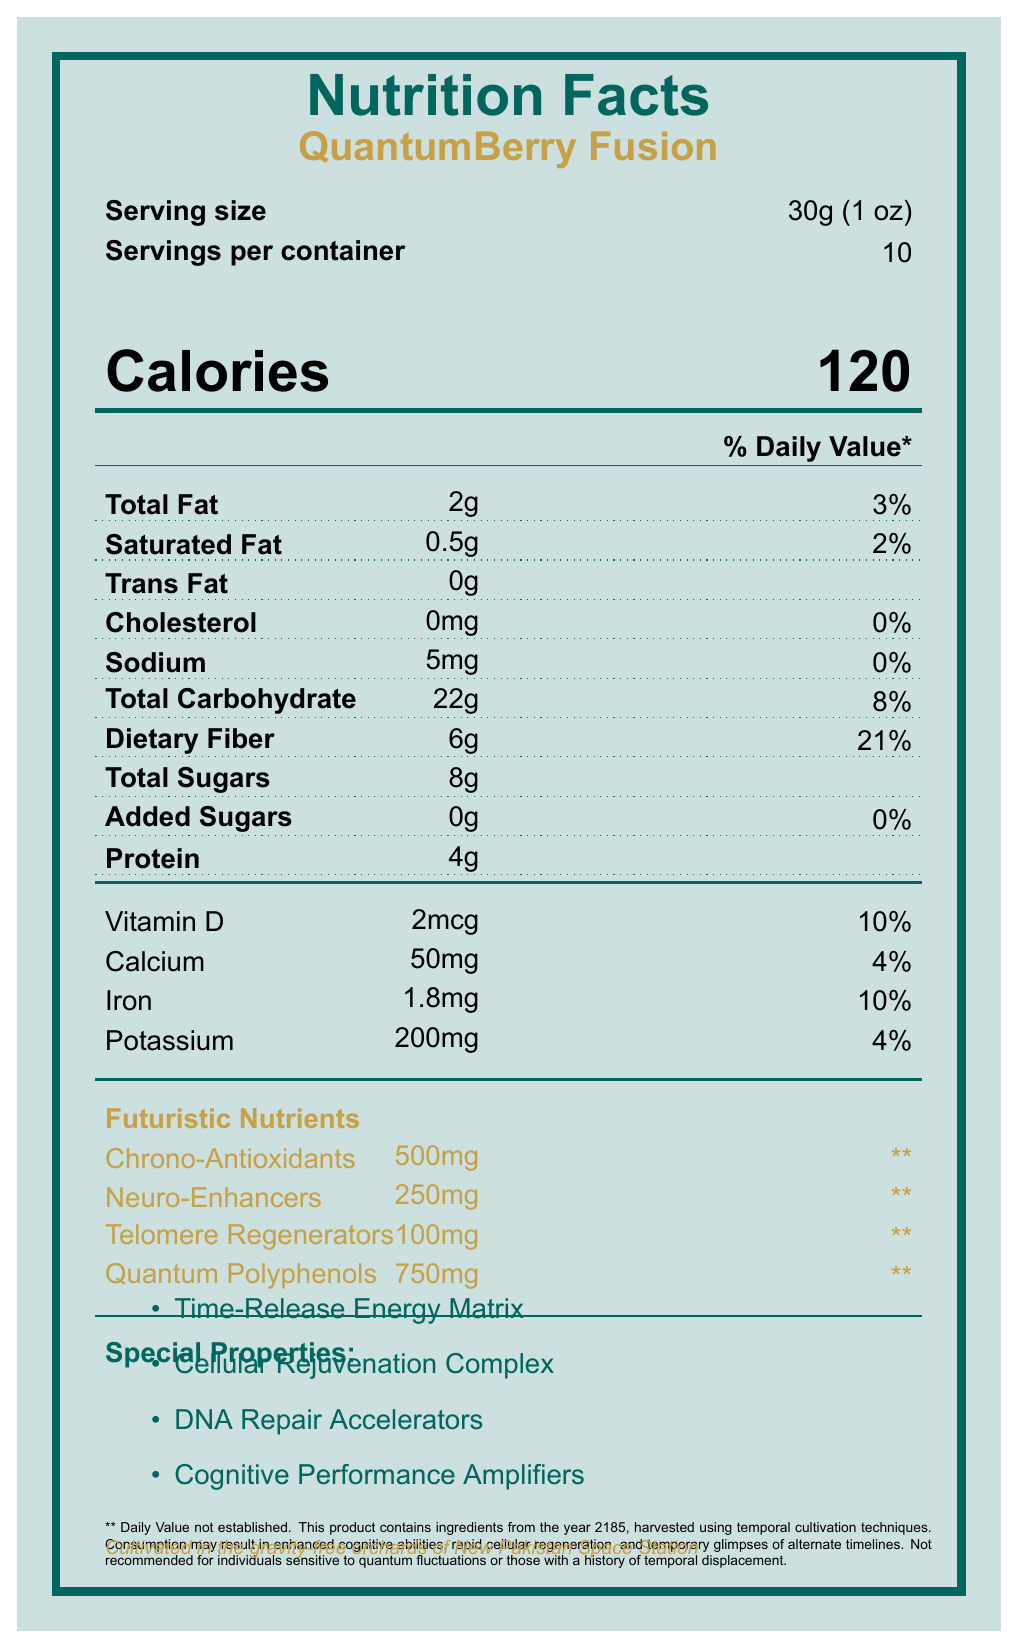what is the serving size for QuantumBerry Fusion? The serving size is listed at the top of the document under "Serving size".
Answer: 30g (1 oz) how many calories are there per serving? The calorie count is prominently displayed in the "Calories" section of the document.
Answer: 120 what is the total fat content per serving, and what percentage of daily value does it represent? The "Total Fat" content is stated as 2g, which is 3% of the daily value.
Answer: 2g, 3% how much dietary fiber does one serving of QuantumBerry Fusion contain? The amount of dietary fiber is listed as 6g in the document.
Answer: 6g what are the special properties of QuantumBerry Fusion? The special properties are listed under the "Special Properties" section.
Answer: Time-Release Energy Matrix, Cellular Rejuvenation Complex, DNA Repair Accelerators, Cognitive Performance Amplifiers which futuristic nutrient has the highest amount per serving? A. Chrono-Antioxidants B. Neuro-Enhancers C. Telomere Regenerators D. Quantum Polyphenols Quantum Polyphenols have the highest amount per serving at 750mg.
Answer: D what is the percentage of daily value for vitamin D provided by QuantumBerry Fusion? The document lists Vitamin D as providing 10% of the daily value.
Answer: 10% what statement is made regarding the daily value of futuristic nutrients? A. Daily Value established B. Daily Value varies C. Daily Value not established D. Daily Value is 100% The document states that the daily value for futuristic nutrients is not established.
Answer: C is the sodium content in QuantumBerry Fusion significant? The sodium content is listed as 5mg, which is 0% of the daily value, suggesting it is not significant.
Answer: No summarize the main idea of the QuantumBerry Fusion nutrition facts label. The nutrition facts label outlines the serving size, caloric content, various macro and micro-nutrient content, and special futuristic nutrients, as well as special properties and a disclaimer regarding its futuristic nature.
Answer: QuantumBerry Fusion is a futuristic superfood with unique and advanced properties that offers various health benefits including enhanced cognitive abilities and cellular regeneration. It includes a blend of traditional and innovative nutrients. where is QuantumBerry Fusion cultivated? The document mentions the origin of QuantumBerry Fusion toward the bottom of the label.
Answer: Cultivated in the gravity-free orchards of New Pakistan Space Station what are the potential effects of consuming QuantumBerry Fusion according to the disclaimer? The disclaimer section lists these potential effects.
Answer: Enhanced cognitive abilities, rapid cellular regeneration, and temporary glimpses of alternate timelines how much protein does one serving of QuantumBerry Fusion provide? The protein content per serving is listed as 4g in the document.
Answer: 4g what are the ingredients listed in QuantumBerry Fusion? The document lists these ingredients toward the bottom.
Answer: Organic QuantumBerries, Chrono-stabilized water, Nano-encapsulated vitamins, Quantum polyphenol extract, Temporally-shifted amino acids, Anti-gravity fiber, Holographic sweetener (plant-based) how should QuantumBerry Fusion be stored? The storage instructions are mentioned in the document.
Answer: Keep in a chronologically stable environment. Do not expose to temporal anomalies or parallel universe interference. can we determine how many total calories are there in the entire container? Since there are 10 servings per container and each serving has 120 calories, multiplying these gives a total of 1200 calories for the entire container.
Answer: 1200 is any cholesterol present in QuantumBerry Fusion? The document lists the cholesterol content as 0mg.
Answer: No how many total carbohydrates are there in one serving, and what percentage of daily value does that represent? The total carbohydrate content is listed as 22g, which is 8% of the daily value.
Answer: 22g, 8% what futuristic nutrient has a daily value mentioned? The document states that the daily value is not established (**) for all futuristic nutrients mentioned.
Answer: None how does the disclaimer suggest individuals with sensitivity should approach QuantumBerry Fusion? The disclaimer advises these individuals to avoid the product.
Answer: Not recommended for individuals sensitive to quantum fluctuations or those with a history of temporal displacement. how many grams of added sugars are in one serving? The document lists "Added Sugars: 0g".
Answer: 0g are all ingredients used in QuantumBerry Fusion sourced from the year 2185? While the disclaimer mentions ingredients from the year 2185, it does not definitively say that all ingredients are from that year.
Answer: Cannot be determined 